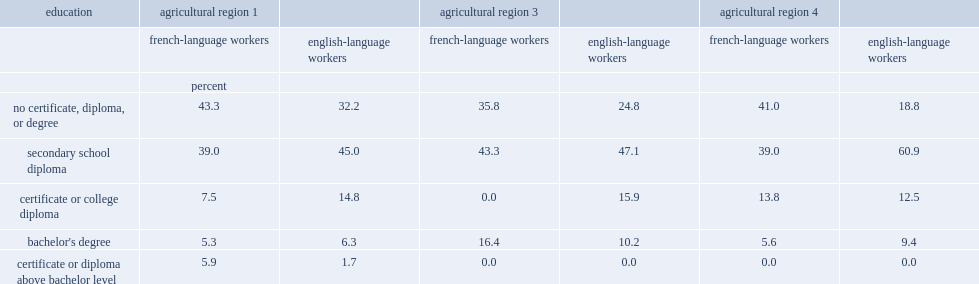In 2011, which sector of workers were more likely to have no certificate, diploma or degree? French-language workers french-language workers french-language workers. 